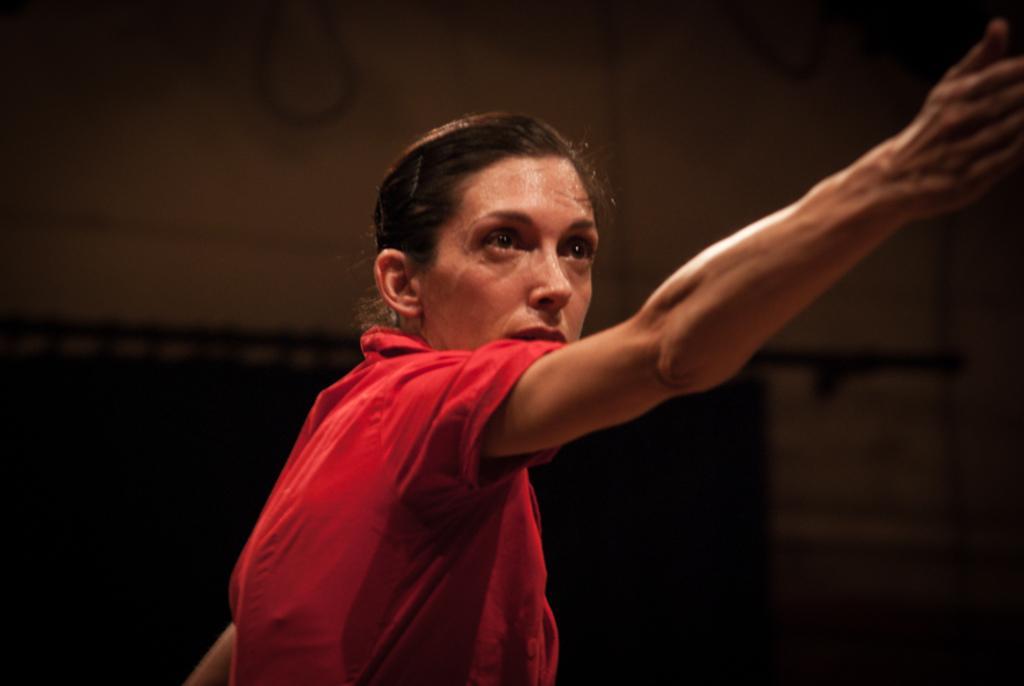In one or two sentences, can you explain what this image depicts? Background portion of the picture is dark. In this picture we can see a woman stretching her hand and wearing a red dress. 